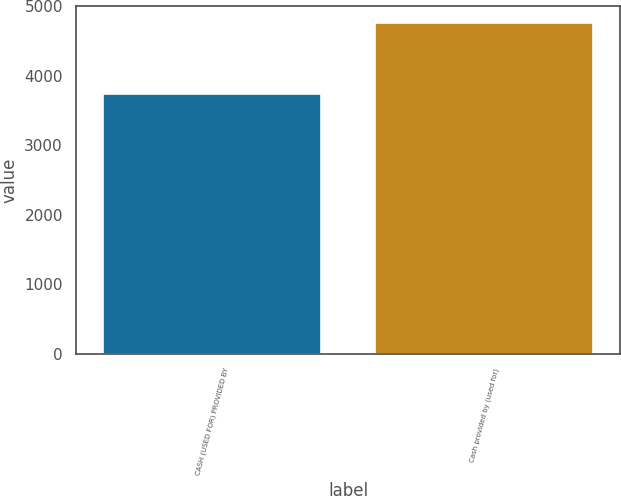<chart> <loc_0><loc_0><loc_500><loc_500><bar_chart><fcel>CASH (USED FOR) PROVIDED BY<fcel>Cash provided by (used for)<nl><fcel>3731<fcel>4762<nl></chart> 